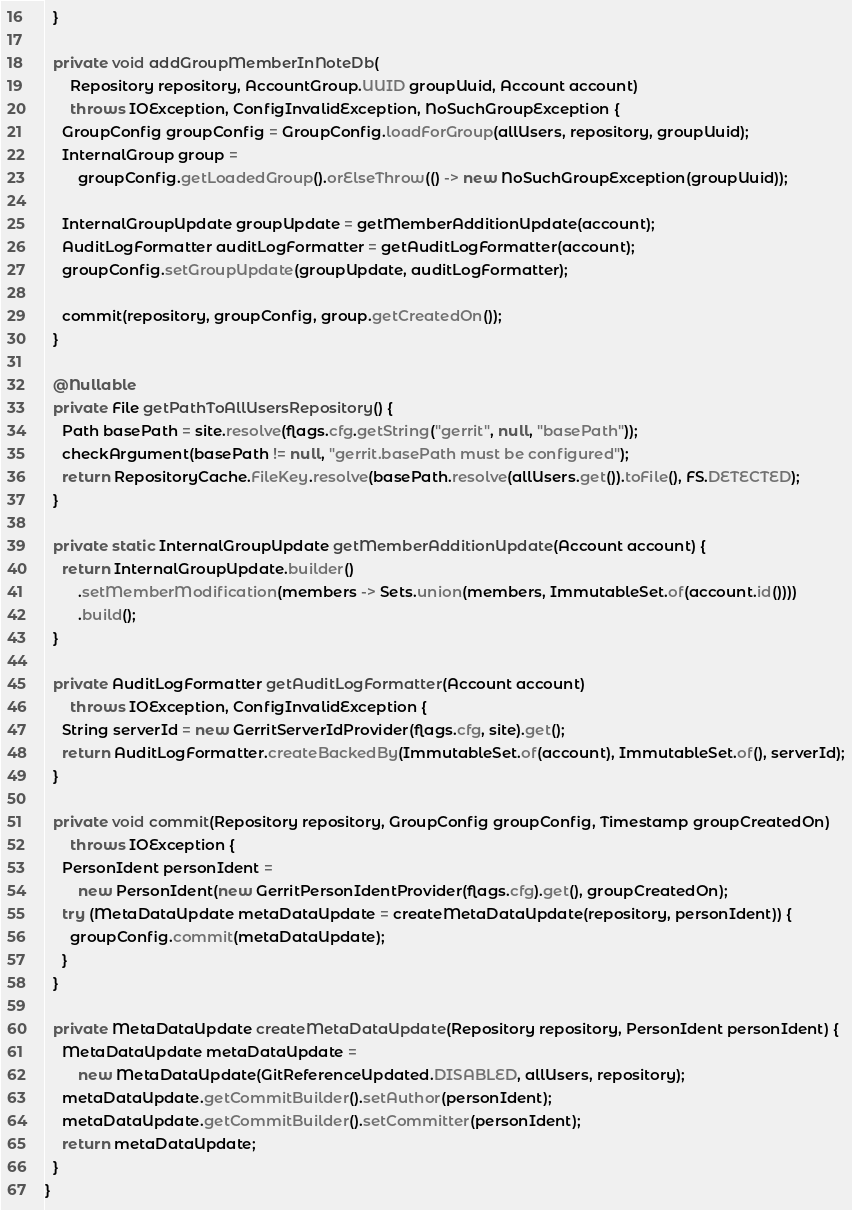<code> <loc_0><loc_0><loc_500><loc_500><_Java_>  }

  private void addGroupMemberInNoteDb(
      Repository repository, AccountGroup.UUID groupUuid, Account account)
      throws IOException, ConfigInvalidException, NoSuchGroupException {
    GroupConfig groupConfig = GroupConfig.loadForGroup(allUsers, repository, groupUuid);
    InternalGroup group =
        groupConfig.getLoadedGroup().orElseThrow(() -> new NoSuchGroupException(groupUuid));

    InternalGroupUpdate groupUpdate = getMemberAdditionUpdate(account);
    AuditLogFormatter auditLogFormatter = getAuditLogFormatter(account);
    groupConfig.setGroupUpdate(groupUpdate, auditLogFormatter);

    commit(repository, groupConfig, group.getCreatedOn());
  }

  @Nullable
  private File getPathToAllUsersRepository() {
    Path basePath = site.resolve(flags.cfg.getString("gerrit", null, "basePath"));
    checkArgument(basePath != null, "gerrit.basePath must be configured");
    return RepositoryCache.FileKey.resolve(basePath.resolve(allUsers.get()).toFile(), FS.DETECTED);
  }

  private static InternalGroupUpdate getMemberAdditionUpdate(Account account) {
    return InternalGroupUpdate.builder()
        .setMemberModification(members -> Sets.union(members, ImmutableSet.of(account.id())))
        .build();
  }

  private AuditLogFormatter getAuditLogFormatter(Account account)
      throws IOException, ConfigInvalidException {
    String serverId = new GerritServerIdProvider(flags.cfg, site).get();
    return AuditLogFormatter.createBackedBy(ImmutableSet.of(account), ImmutableSet.of(), serverId);
  }

  private void commit(Repository repository, GroupConfig groupConfig, Timestamp groupCreatedOn)
      throws IOException {
    PersonIdent personIdent =
        new PersonIdent(new GerritPersonIdentProvider(flags.cfg).get(), groupCreatedOn);
    try (MetaDataUpdate metaDataUpdate = createMetaDataUpdate(repository, personIdent)) {
      groupConfig.commit(metaDataUpdate);
    }
  }

  private MetaDataUpdate createMetaDataUpdate(Repository repository, PersonIdent personIdent) {
    MetaDataUpdate metaDataUpdate =
        new MetaDataUpdate(GitReferenceUpdated.DISABLED, allUsers, repository);
    metaDataUpdate.getCommitBuilder().setAuthor(personIdent);
    metaDataUpdate.getCommitBuilder().setCommitter(personIdent);
    return metaDataUpdate;
  }
}
</code> 